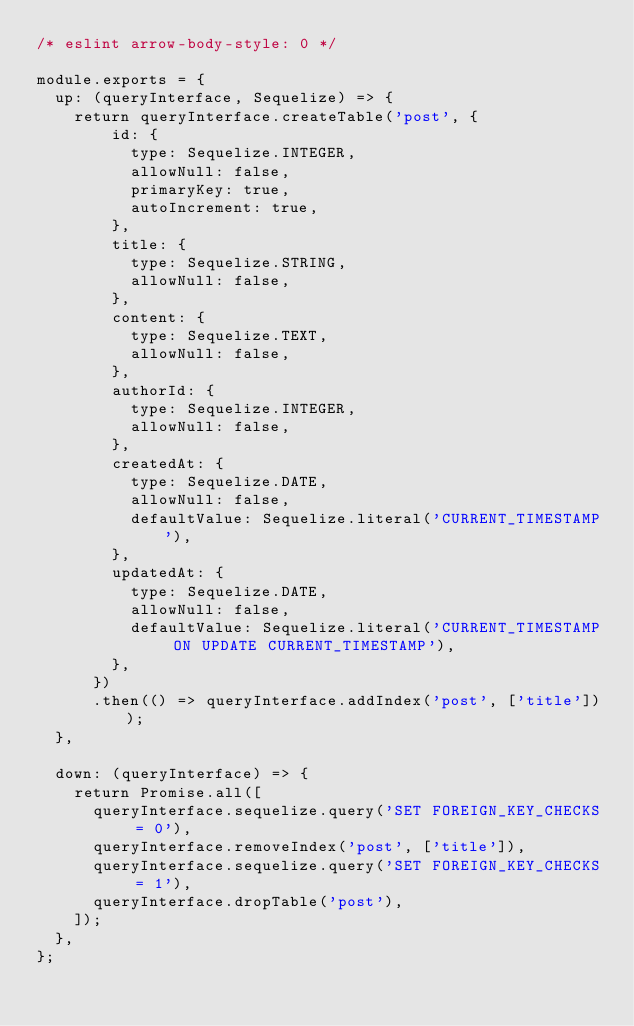<code> <loc_0><loc_0><loc_500><loc_500><_JavaScript_>/* eslint arrow-body-style: 0 */

module.exports = {
  up: (queryInterface, Sequelize) => {
    return queryInterface.createTable('post', {
        id: {
          type: Sequelize.INTEGER,
          allowNull: false,
          primaryKey: true,
          autoIncrement: true,
        },
        title: {
          type: Sequelize.STRING,
          allowNull: false,
        },
        content: {
          type: Sequelize.TEXT,
          allowNull: false,
        },
        authorId: {
          type: Sequelize.INTEGER,
          allowNull: false,
        },
        createdAt: {
          type: Sequelize.DATE,
          allowNull: false,
          defaultValue: Sequelize.literal('CURRENT_TIMESTAMP'),
        },
        updatedAt: {
          type: Sequelize.DATE,
          allowNull: false,
          defaultValue: Sequelize.literal('CURRENT_TIMESTAMP ON UPDATE CURRENT_TIMESTAMP'),
        },
      })
      .then(() => queryInterface.addIndex('post', ['title']));
  },

  down: (queryInterface) => {
    return Promise.all([
      queryInterface.sequelize.query('SET FOREIGN_KEY_CHECKS = 0'),
      queryInterface.removeIndex('post', ['title']),
      queryInterface.sequelize.query('SET FOREIGN_KEY_CHECKS = 1'),
      queryInterface.dropTable('post'),
    ]);
  },
};
</code> 